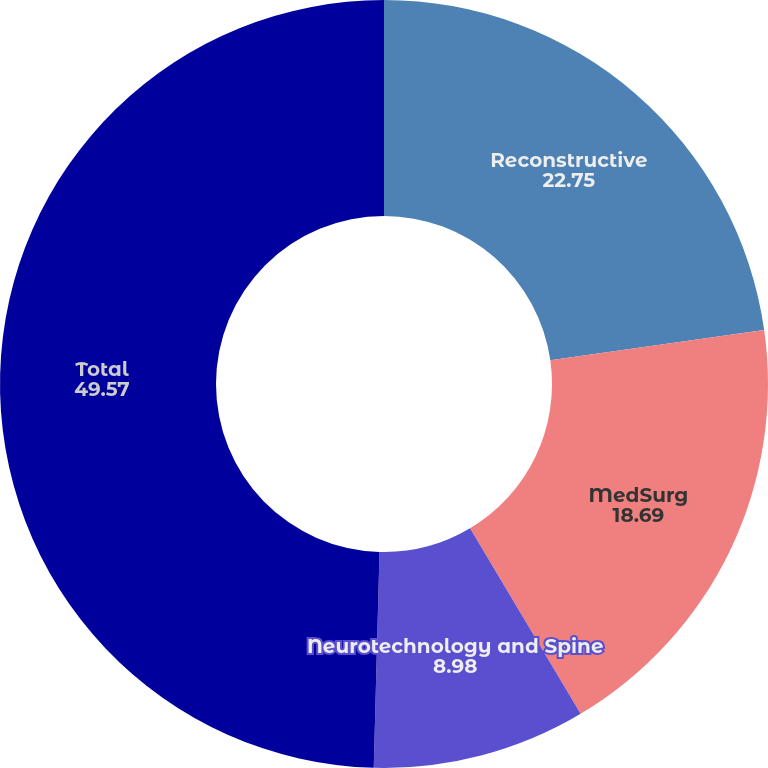Convert chart. <chart><loc_0><loc_0><loc_500><loc_500><pie_chart><fcel>Reconstructive<fcel>MedSurg<fcel>Neurotechnology and Spine<fcel>Total<nl><fcel>22.75%<fcel>18.69%<fcel>8.98%<fcel>49.57%<nl></chart> 